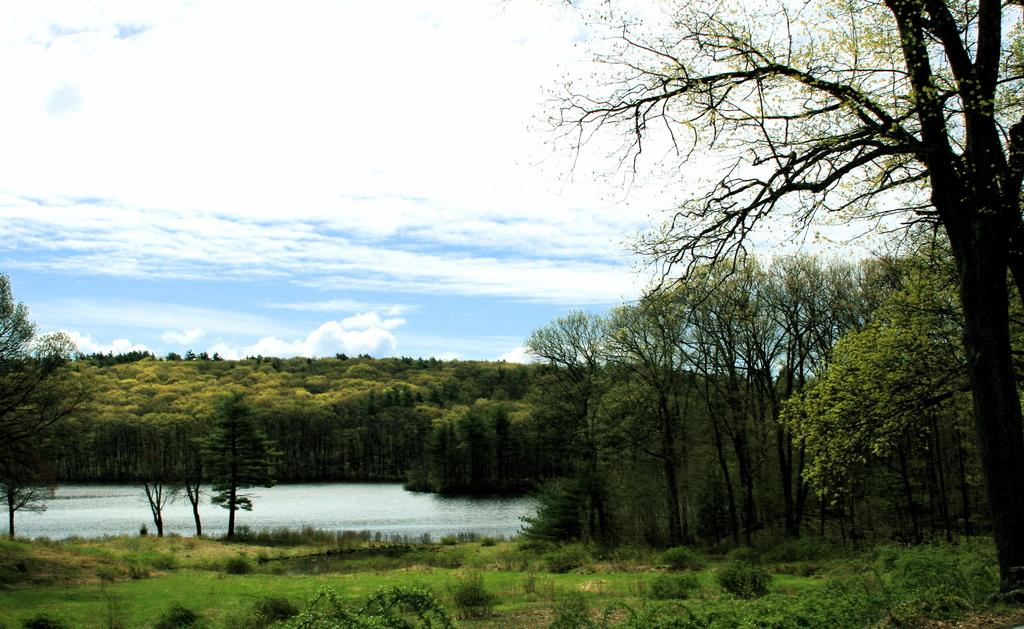What type of vegetation can be seen in the image? There is grass and plants visible in the image. What else can be seen in the image besides vegetation? There is water visible in the image. What is visible in the background of the image? There are trees and a clear sky visible in the background of the image. How does the friction between the grass and the cows affect the stream in the image? There are no cows present in the image, and therefore no friction between the grass and cows can be observed. 